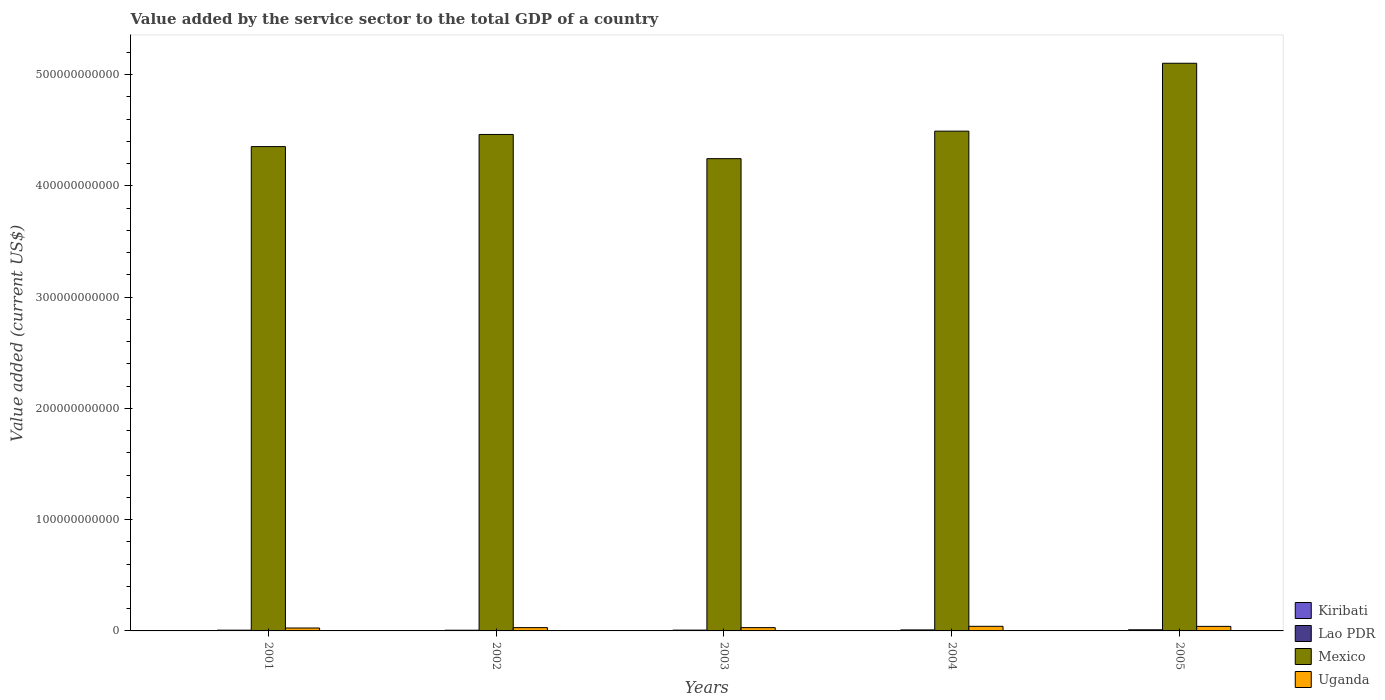How many different coloured bars are there?
Ensure brevity in your answer.  4. How many groups of bars are there?
Your response must be concise. 5. Are the number of bars on each tick of the X-axis equal?
Provide a short and direct response. Yes. How many bars are there on the 3rd tick from the right?
Your answer should be compact. 4. What is the label of the 2nd group of bars from the left?
Provide a short and direct response. 2002. In how many cases, is the number of bars for a given year not equal to the number of legend labels?
Offer a very short reply. 0. What is the value added by the service sector to the total GDP in Uganda in 2005?
Give a very brief answer. 4.08e+09. Across all years, what is the maximum value added by the service sector to the total GDP in Lao PDR?
Your answer should be very brief. 1.01e+09. Across all years, what is the minimum value added by the service sector to the total GDP in Lao PDR?
Your answer should be compact. 6.28e+08. In which year was the value added by the service sector to the total GDP in Uganda minimum?
Your answer should be compact. 2001. What is the total value added by the service sector to the total GDP in Uganda in the graph?
Provide a succinct answer. 1.67e+1. What is the difference between the value added by the service sector to the total GDP in Kiribati in 2004 and that in 2005?
Your answer should be very brief. -8.06e+06. What is the difference between the value added by the service sector to the total GDP in Mexico in 2003 and the value added by the service sector to the total GDP in Lao PDR in 2001?
Your answer should be compact. 4.24e+11. What is the average value added by the service sector to the total GDP in Lao PDR per year?
Offer a terse response. 7.89e+08. In the year 2005, what is the difference between the value added by the service sector to the total GDP in Uganda and value added by the service sector to the total GDP in Lao PDR?
Ensure brevity in your answer.  3.07e+09. In how many years, is the value added by the service sector to the total GDP in Uganda greater than 80000000000 US$?
Keep it short and to the point. 0. What is the ratio of the value added by the service sector to the total GDP in Mexico in 2004 to that in 2005?
Offer a very short reply. 0.88. Is the difference between the value added by the service sector to the total GDP in Uganda in 2001 and 2005 greater than the difference between the value added by the service sector to the total GDP in Lao PDR in 2001 and 2005?
Keep it short and to the point. No. What is the difference between the highest and the second highest value added by the service sector to the total GDP in Lao PDR?
Your answer should be very brief. 1.09e+08. What is the difference between the highest and the lowest value added by the service sector to the total GDP in Lao PDR?
Your answer should be compact. 3.85e+08. Is the sum of the value added by the service sector to the total GDP in Lao PDR in 2002 and 2004 greater than the maximum value added by the service sector to the total GDP in Mexico across all years?
Provide a succinct answer. No. Is it the case that in every year, the sum of the value added by the service sector to the total GDP in Uganda and value added by the service sector to the total GDP in Lao PDR is greater than the sum of value added by the service sector to the total GDP in Mexico and value added by the service sector to the total GDP in Kiribati?
Your response must be concise. Yes. What does the 3rd bar from the left in 2001 represents?
Make the answer very short. Mexico. What does the 1st bar from the right in 2005 represents?
Offer a terse response. Uganda. Is it the case that in every year, the sum of the value added by the service sector to the total GDP in Uganda and value added by the service sector to the total GDP in Lao PDR is greater than the value added by the service sector to the total GDP in Mexico?
Give a very brief answer. No. How many bars are there?
Offer a very short reply. 20. Are all the bars in the graph horizontal?
Make the answer very short. No. How many years are there in the graph?
Give a very brief answer. 5. What is the difference between two consecutive major ticks on the Y-axis?
Your response must be concise. 1.00e+11. Does the graph contain any zero values?
Offer a very short reply. No. Does the graph contain grids?
Give a very brief answer. No. Where does the legend appear in the graph?
Give a very brief answer. Bottom right. How many legend labels are there?
Ensure brevity in your answer.  4. What is the title of the graph?
Keep it short and to the point. Value added by the service sector to the total GDP of a country. What is the label or title of the X-axis?
Provide a short and direct response. Years. What is the label or title of the Y-axis?
Give a very brief answer. Value added (current US$). What is the Value added (current US$) of Kiribati in 2001?
Offer a terse response. 3.75e+07. What is the Value added (current US$) of Lao PDR in 2001?
Ensure brevity in your answer.  6.82e+08. What is the Value added (current US$) in Mexico in 2001?
Your answer should be very brief. 4.35e+11. What is the Value added (current US$) in Uganda in 2001?
Your answer should be very brief. 2.62e+09. What is the Value added (current US$) in Kiribati in 2002?
Offer a very short reply. 4.17e+07. What is the Value added (current US$) of Lao PDR in 2002?
Keep it short and to the point. 6.28e+08. What is the Value added (current US$) of Mexico in 2002?
Your answer should be very brief. 4.46e+11. What is the Value added (current US$) in Uganda in 2002?
Keep it short and to the point. 2.95e+09. What is the Value added (current US$) in Kiribati in 2003?
Your answer should be very brief. 5.20e+07. What is the Value added (current US$) of Lao PDR in 2003?
Give a very brief answer. 7.19e+08. What is the Value added (current US$) of Mexico in 2003?
Keep it short and to the point. 4.24e+11. What is the Value added (current US$) in Uganda in 2003?
Your answer should be very brief. 2.95e+09. What is the Value added (current US$) of Kiribati in 2004?
Offer a very short reply. 5.83e+07. What is the Value added (current US$) of Lao PDR in 2004?
Provide a succinct answer. 9.04e+08. What is the Value added (current US$) in Mexico in 2004?
Provide a short and direct response. 4.49e+11. What is the Value added (current US$) of Uganda in 2004?
Offer a terse response. 4.13e+09. What is the Value added (current US$) in Kiribati in 2005?
Your response must be concise. 6.63e+07. What is the Value added (current US$) of Lao PDR in 2005?
Your response must be concise. 1.01e+09. What is the Value added (current US$) in Mexico in 2005?
Make the answer very short. 5.10e+11. What is the Value added (current US$) of Uganda in 2005?
Ensure brevity in your answer.  4.08e+09. Across all years, what is the maximum Value added (current US$) in Kiribati?
Give a very brief answer. 6.63e+07. Across all years, what is the maximum Value added (current US$) in Lao PDR?
Provide a short and direct response. 1.01e+09. Across all years, what is the maximum Value added (current US$) in Mexico?
Ensure brevity in your answer.  5.10e+11. Across all years, what is the maximum Value added (current US$) in Uganda?
Give a very brief answer. 4.13e+09. Across all years, what is the minimum Value added (current US$) in Kiribati?
Your answer should be very brief. 3.75e+07. Across all years, what is the minimum Value added (current US$) of Lao PDR?
Provide a succinct answer. 6.28e+08. Across all years, what is the minimum Value added (current US$) in Mexico?
Make the answer very short. 4.24e+11. Across all years, what is the minimum Value added (current US$) in Uganda?
Ensure brevity in your answer.  2.62e+09. What is the total Value added (current US$) in Kiribati in the graph?
Offer a very short reply. 2.56e+08. What is the total Value added (current US$) of Lao PDR in the graph?
Provide a short and direct response. 3.94e+09. What is the total Value added (current US$) in Mexico in the graph?
Ensure brevity in your answer.  2.26e+12. What is the total Value added (current US$) of Uganda in the graph?
Provide a short and direct response. 1.67e+1. What is the difference between the Value added (current US$) in Kiribati in 2001 and that in 2002?
Offer a terse response. -4.19e+06. What is the difference between the Value added (current US$) of Lao PDR in 2001 and that in 2002?
Ensure brevity in your answer.  5.40e+07. What is the difference between the Value added (current US$) of Mexico in 2001 and that in 2002?
Make the answer very short. -1.09e+1. What is the difference between the Value added (current US$) of Uganda in 2001 and that in 2002?
Ensure brevity in your answer.  -3.34e+08. What is the difference between the Value added (current US$) in Kiribati in 2001 and that in 2003?
Your answer should be very brief. -1.45e+07. What is the difference between the Value added (current US$) of Lao PDR in 2001 and that in 2003?
Ensure brevity in your answer.  -3.73e+07. What is the difference between the Value added (current US$) in Mexico in 2001 and that in 2003?
Provide a short and direct response. 1.08e+1. What is the difference between the Value added (current US$) of Uganda in 2001 and that in 2003?
Provide a short and direct response. -3.34e+08. What is the difference between the Value added (current US$) of Kiribati in 2001 and that in 2004?
Offer a very short reply. -2.07e+07. What is the difference between the Value added (current US$) in Lao PDR in 2001 and that in 2004?
Keep it short and to the point. -2.22e+08. What is the difference between the Value added (current US$) of Mexico in 2001 and that in 2004?
Your answer should be compact. -1.39e+1. What is the difference between the Value added (current US$) of Uganda in 2001 and that in 2004?
Your answer should be compact. -1.52e+09. What is the difference between the Value added (current US$) of Kiribati in 2001 and that in 2005?
Offer a very short reply. -2.88e+07. What is the difference between the Value added (current US$) in Lao PDR in 2001 and that in 2005?
Provide a succinct answer. -3.30e+08. What is the difference between the Value added (current US$) in Mexico in 2001 and that in 2005?
Keep it short and to the point. -7.49e+1. What is the difference between the Value added (current US$) of Uganda in 2001 and that in 2005?
Make the answer very short. -1.47e+09. What is the difference between the Value added (current US$) in Kiribati in 2002 and that in 2003?
Offer a terse response. -1.03e+07. What is the difference between the Value added (current US$) of Lao PDR in 2002 and that in 2003?
Make the answer very short. -9.13e+07. What is the difference between the Value added (current US$) of Mexico in 2002 and that in 2003?
Your response must be concise. 2.17e+1. What is the difference between the Value added (current US$) in Uganda in 2002 and that in 2003?
Your answer should be compact. 7.68e+05. What is the difference between the Value added (current US$) of Kiribati in 2002 and that in 2004?
Your answer should be very brief. -1.65e+07. What is the difference between the Value added (current US$) of Lao PDR in 2002 and that in 2004?
Your answer should be compact. -2.76e+08. What is the difference between the Value added (current US$) of Mexico in 2002 and that in 2004?
Keep it short and to the point. -2.97e+09. What is the difference between the Value added (current US$) of Uganda in 2002 and that in 2004?
Offer a very short reply. -1.18e+09. What is the difference between the Value added (current US$) in Kiribati in 2002 and that in 2005?
Your answer should be very brief. -2.46e+07. What is the difference between the Value added (current US$) in Lao PDR in 2002 and that in 2005?
Your response must be concise. -3.85e+08. What is the difference between the Value added (current US$) in Mexico in 2002 and that in 2005?
Give a very brief answer. -6.40e+1. What is the difference between the Value added (current US$) in Uganda in 2002 and that in 2005?
Your response must be concise. -1.13e+09. What is the difference between the Value added (current US$) in Kiribati in 2003 and that in 2004?
Ensure brevity in your answer.  -6.27e+06. What is the difference between the Value added (current US$) of Lao PDR in 2003 and that in 2004?
Your answer should be compact. -1.85e+08. What is the difference between the Value added (current US$) of Mexico in 2003 and that in 2004?
Your response must be concise. -2.47e+1. What is the difference between the Value added (current US$) of Uganda in 2003 and that in 2004?
Offer a very short reply. -1.18e+09. What is the difference between the Value added (current US$) of Kiribati in 2003 and that in 2005?
Keep it short and to the point. -1.43e+07. What is the difference between the Value added (current US$) in Lao PDR in 2003 and that in 2005?
Your response must be concise. -2.93e+08. What is the difference between the Value added (current US$) in Mexico in 2003 and that in 2005?
Provide a short and direct response. -8.57e+1. What is the difference between the Value added (current US$) in Uganda in 2003 and that in 2005?
Your answer should be very brief. -1.14e+09. What is the difference between the Value added (current US$) of Kiribati in 2004 and that in 2005?
Offer a terse response. -8.06e+06. What is the difference between the Value added (current US$) of Lao PDR in 2004 and that in 2005?
Make the answer very short. -1.09e+08. What is the difference between the Value added (current US$) in Mexico in 2004 and that in 2005?
Provide a succinct answer. -6.10e+1. What is the difference between the Value added (current US$) of Uganda in 2004 and that in 2005?
Your answer should be compact. 4.72e+07. What is the difference between the Value added (current US$) in Kiribati in 2001 and the Value added (current US$) in Lao PDR in 2002?
Your answer should be very brief. -5.90e+08. What is the difference between the Value added (current US$) of Kiribati in 2001 and the Value added (current US$) of Mexico in 2002?
Provide a succinct answer. -4.46e+11. What is the difference between the Value added (current US$) in Kiribati in 2001 and the Value added (current US$) in Uganda in 2002?
Make the answer very short. -2.91e+09. What is the difference between the Value added (current US$) in Lao PDR in 2001 and the Value added (current US$) in Mexico in 2002?
Offer a terse response. -4.45e+11. What is the difference between the Value added (current US$) in Lao PDR in 2001 and the Value added (current US$) in Uganda in 2002?
Offer a terse response. -2.27e+09. What is the difference between the Value added (current US$) of Mexico in 2001 and the Value added (current US$) of Uganda in 2002?
Keep it short and to the point. 4.32e+11. What is the difference between the Value added (current US$) of Kiribati in 2001 and the Value added (current US$) of Lao PDR in 2003?
Offer a terse response. -6.81e+08. What is the difference between the Value added (current US$) of Kiribati in 2001 and the Value added (current US$) of Mexico in 2003?
Offer a very short reply. -4.24e+11. What is the difference between the Value added (current US$) in Kiribati in 2001 and the Value added (current US$) in Uganda in 2003?
Your response must be concise. -2.91e+09. What is the difference between the Value added (current US$) in Lao PDR in 2001 and the Value added (current US$) in Mexico in 2003?
Your answer should be compact. -4.24e+11. What is the difference between the Value added (current US$) in Lao PDR in 2001 and the Value added (current US$) in Uganda in 2003?
Offer a terse response. -2.27e+09. What is the difference between the Value added (current US$) in Mexico in 2001 and the Value added (current US$) in Uganda in 2003?
Ensure brevity in your answer.  4.32e+11. What is the difference between the Value added (current US$) in Kiribati in 2001 and the Value added (current US$) in Lao PDR in 2004?
Provide a succinct answer. -8.66e+08. What is the difference between the Value added (current US$) of Kiribati in 2001 and the Value added (current US$) of Mexico in 2004?
Provide a succinct answer. -4.49e+11. What is the difference between the Value added (current US$) in Kiribati in 2001 and the Value added (current US$) in Uganda in 2004?
Your answer should be very brief. -4.09e+09. What is the difference between the Value added (current US$) in Lao PDR in 2001 and the Value added (current US$) in Mexico in 2004?
Your answer should be compact. -4.48e+11. What is the difference between the Value added (current US$) in Lao PDR in 2001 and the Value added (current US$) in Uganda in 2004?
Provide a succinct answer. -3.45e+09. What is the difference between the Value added (current US$) in Mexico in 2001 and the Value added (current US$) in Uganda in 2004?
Keep it short and to the point. 4.31e+11. What is the difference between the Value added (current US$) of Kiribati in 2001 and the Value added (current US$) of Lao PDR in 2005?
Provide a succinct answer. -9.75e+08. What is the difference between the Value added (current US$) of Kiribati in 2001 and the Value added (current US$) of Mexico in 2005?
Give a very brief answer. -5.10e+11. What is the difference between the Value added (current US$) of Kiribati in 2001 and the Value added (current US$) of Uganda in 2005?
Make the answer very short. -4.05e+09. What is the difference between the Value added (current US$) of Lao PDR in 2001 and the Value added (current US$) of Mexico in 2005?
Offer a terse response. -5.09e+11. What is the difference between the Value added (current US$) of Lao PDR in 2001 and the Value added (current US$) of Uganda in 2005?
Ensure brevity in your answer.  -3.40e+09. What is the difference between the Value added (current US$) in Mexico in 2001 and the Value added (current US$) in Uganda in 2005?
Offer a very short reply. 4.31e+11. What is the difference between the Value added (current US$) in Kiribati in 2002 and the Value added (current US$) in Lao PDR in 2003?
Your response must be concise. -6.77e+08. What is the difference between the Value added (current US$) in Kiribati in 2002 and the Value added (current US$) in Mexico in 2003?
Your answer should be very brief. -4.24e+11. What is the difference between the Value added (current US$) of Kiribati in 2002 and the Value added (current US$) of Uganda in 2003?
Give a very brief answer. -2.91e+09. What is the difference between the Value added (current US$) in Lao PDR in 2002 and the Value added (current US$) in Mexico in 2003?
Keep it short and to the point. -4.24e+11. What is the difference between the Value added (current US$) in Lao PDR in 2002 and the Value added (current US$) in Uganda in 2003?
Offer a very short reply. -2.32e+09. What is the difference between the Value added (current US$) in Mexico in 2002 and the Value added (current US$) in Uganda in 2003?
Ensure brevity in your answer.  4.43e+11. What is the difference between the Value added (current US$) of Kiribati in 2002 and the Value added (current US$) of Lao PDR in 2004?
Your answer should be very brief. -8.62e+08. What is the difference between the Value added (current US$) in Kiribati in 2002 and the Value added (current US$) in Mexico in 2004?
Make the answer very short. -4.49e+11. What is the difference between the Value added (current US$) of Kiribati in 2002 and the Value added (current US$) of Uganda in 2004?
Give a very brief answer. -4.09e+09. What is the difference between the Value added (current US$) in Lao PDR in 2002 and the Value added (current US$) in Mexico in 2004?
Give a very brief answer. -4.48e+11. What is the difference between the Value added (current US$) in Lao PDR in 2002 and the Value added (current US$) in Uganda in 2004?
Offer a terse response. -3.50e+09. What is the difference between the Value added (current US$) in Mexico in 2002 and the Value added (current US$) in Uganda in 2004?
Ensure brevity in your answer.  4.42e+11. What is the difference between the Value added (current US$) in Kiribati in 2002 and the Value added (current US$) in Lao PDR in 2005?
Your response must be concise. -9.70e+08. What is the difference between the Value added (current US$) in Kiribati in 2002 and the Value added (current US$) in Mexico in 2005?
Your answer should be compact. -5.10e+11. What is the difference between the Value added (current US$) of Kiribati in 2002 and the Value added (current US$) of Uganda in 2005?
Your answer should be compact. -4.04e+09. What is the difference between the Value added (current US$) of Lao PDR in 2002 and the Value added (current US$) of Mexico in 2005?
Provide a short and direct response. -5.09e+11. What is the difference between the Value added (current US$) of Lao PDR in 2002 and the Value added (current US$) of Uganda in 2005?
Your answer should be very brief. -3.46e+09. What is the difference between the Value added (current US$) of Mexico in 2002 and the Value added (current US$) of Uganda in 2005?
Ensure brevity in your answer.  4.42e+11. What is the difference between the Value added (current US$) in Kiribati in 2003 and the Value added (current US$) in Lao PDR in 2004?
Provide a short and direct response. -8.52e+08. What is the difference between the Value added (current US$) of Kiribati in 2003 and the Value added (current US$) of Mexico in 2004?
Your answer should be compact. -4.49e+11. What is the difference between the Value added (current US$) in Kiribati in 2003 and the Value added (current US$) in Uganda in 2004?
Provide a short and direct response. -4.08e+09. What is the difference between the Value added (current US$) in Lao PDR in 2003 and the Value added (current US$) in Mexico in 2004?
Provide a succinct answer. -4.48e+11. What is the difference between the Value added (current US$) in Lao PDR in 2003 and the Value added (current US$) in Uganda in 2004?
Provide a short and direct response. -3.41e+09. What is the difference between the Value added (current US$) in Mexico in 2003 and the Value added (current US$) in Uganda in 2004?
Your answer should be compact. 4.20e+11. What is the difference between the Value added (current US$) of Kiribati in 2003 and the Value added (current US$) of Lao PDR in 2005?
Your response must be concise. -9.60e+08. What is the difference between the Value added (current US$) of Kiribati in 2003 and the Value added (current US$) of Mexico in 2005?
Give a very brief answer. -5.10e+11. What is the difference between the Value added (current US$) of Kiribati in 2003 and the Value added (current US$) of Uganda in 2005?
Offer a very short reply. -4.03e+09. What is the difference between the Value added (current US$) in Lao PDR in 2003 and the Value added (current US$) in Mexico in 2005?
Offer a terse response. -5.09e+11. What is the difference between the Value added (current US$) in Lao PDR in 2003 and the Value added (current US$) in Uganda in 2005?
Offer a terse response. -3.37e+09. What is the difference between the Value added (current US$) in Mexico in 2003 and the Value added (current US$) in Uganda in 2005?
Keep it short and to the point. 4.20e+11. What is the difference between the Value added (current US$) of Kiribati in 2004 and the Value added (current US$) of Lao PDR in 2005?
Provide a succinct answer. -9.54e+08. What is the difference between the Value added (current US$) in Kiribati in 2004 and the Value added (current US$) in Mexico in 2005?
Offer a terse response. -5.10e+11. What is the difference between the Value added (current US$) in Kiribati in 2004 and the Value added (current US$) in Uganda in 2005?
Give a very brief answer. -4.03e+09. What is the difference between the Value added (current US$) in Lao PDR in 2004 and the Value added (current US$) in Mexico in 2005?
Keep it short and to the point. -5.09e+11. What is the difference between the Value added (current US$) of Lao PDR in 2004 and the Value added (current US$) of Uganda in 2005?
Your answer should be very brief. -3.18e+09. What is the difference between the Value added (current US$) in Mexico in 2004 and the Value added (current US$) in Uganda in 2005?
Offer a terse response. 4.45e+11. What is the average Value added (current US$) of Kiribati per year?
Your answer should be compact. 5.12e+07. What is the average Value added (current US$) of Lao PDR per year?
Make the answer very short. 7.89e+08. What is the average Value added (current US$) in Mexico per year?
Offer a terse response. 4.53e+11. What is the average Value added (current US$) of Uganda per year?
Your answer should be very brief. 3.35e+09. In the year 2001, what is the difference between the Value added (current US$) in Kiribati and Value added (current US$) in Lao PDR?
Make the answer very short. -6.44e+08. In the year 2001, what is the difference between the Value added (current US$) of Kiribati and Value added (current US$) of Mexico?
Offer a very short reply. -4.35e+11. In the year 2001, what is the difference between the Value added (current US$) of Kiribati and Value added (current US$) of Uganda?
Your answer should be compact. -2.58e+09. In the year 2001, what is the difference between the Value added (current US$) of Lao PDR and Value added (current US$) of Mexico?
Keep it short and to the point. -4.35e+11. In the year 2001, what is the difference between the Value added (current US$) in Lao PDR and Value added (current US$) in Uganda?
Your answer should be compact. -1.93e+09. In the year 2001, what is the difference between the Value added (current US$) of Mexico and Value added (current US$) of Uganda?
Offer a very short reply. 4.33e+11. In the year 2002, what is the difference between the Value added (current US$) in Kiribati and Value added (current US$) in Lao PDR?
Your answer should be very brief. -5.86e+08. In the year 2002, what is the difference between the Value added (current US$) of Kiribati and Value added (current US$) of Mexico?
Provide a succinct answer. -4.46e+11. In the year 2002, what is the difference between the Value added (current US$) in Kiribati and Value added (current US$) in Uganda?
Offer a very short reply. -2.91e+09. In the year 2002, what is the difference between the Value added (current US$) of Lao PDR and Value added (current US$) of Mexico?
Your answer should be very brief. -4.46e+11. In the year 2002, what is the difference between the Value added (current US$) in Lao PDR and Value added (current US$) in Uganda?
Give a very brief answer. -2.32e+09. In the year 2002, what is the difference between the Value added (current US$) in Mexico and Value added (current US$) in Uganda?
Offer a very short reply. 4.43e+11. In the year 2003, what is the difference between the Value added (current US$) of Kiribati and Value added (current US$) of Lao PDR?
Your answer should be very brief. -6.67e+08. In the year 2003, what is the difference between the Value added (current US$) in Kiribati and Value added (current US$) in Mexico?
Provide a short and direct response. -4.24e+11. In the year 2003, what is the difference between the Value added (current US$) in Kiribati and Value added (current US$) in Uganda?
Your response must be concise. -2.90e+09. In the year 2003, what is the difference between the Value added (current US$) of Lao PDR and Value added (current US$) of Mexico?
Offer a very short reply. -4.24e+11. In the year 2003, what is the difference between the Value added (current US$) in Lao PDR and Value added (current US$) in Uganda?
Provide a short and direct response. -2.23e+09. In the year 2003, what is the difference between the Value added (current US$) of Mexico and Value added (current US$) of Uganda?
Give a very brief answer. 4.21e+11. In the year 2004, what is the difference between the Value added (current US$) of Kiribati and Value added (current US$) of Lao PDR?
Your answer should be compact. -8.45e+08. In the year 2004, what is the difference between the Value added (current US$) in Kiribati and Value added (current US$) in Mexico?
Ensure brevity in your answer.  -4.49e+11. In the year 2004, what is the difference between the Value added (current US$) in Kiribati and Value added (current US$) in Uganda?
Offer a terse response. -4.07e+09. In the year 2004, what is the difference between the Value added (current US$) of Lao PDR and Value added (current US$) of Mexico?
Offer a terse response. -4.48e+11. In the year 2004, what is the difference between the Value added (current US$) of Lao PDR and Value added (current US$) of Uganda?
Give a very brief answer. -3.23e+09. In the year 2004, what is the difference between the Value added (current US$) of Mexico and Value added (current US$) of Uganda?
Your answer should be compact. 4.45e+11. In the year 2005, what is the difference between the Value added (current US$) of Kiribati and Value added (current US$) of Lao PDR?
Your answer should be very brief. -9.46e+08. In the year 2005, what is the difference between the Value added (current US$) in Kiribati and Value added (current US$) in Mexico?
Offer a terse response. -5.10e+11. In the year 2005, what is the difference between the Value added (current US$) in Kiribati and Value added (current US$) in Uganda?
Offer a very short reply. -4.02e+09. In the year 2005, what is the difference between the Value added (current US$) in Lao PDR and Value added (current US$) in Mexico?
Provide a short and direct response. -5.09e+11. In the year 2005, what is the difference between the Value added (current US$) of Lao PDR and Value added (current US$) of Uganda?
Offer a very short reply. -3.07e+09. In the year 2005, what is the difference between the Value added (current US$) of Mexico and Value added (current US$) of Uganda?
Ensure brevity in your answer.  5.06e+11. What is the ratio of the Value added (current US$) of Kiribati in 2001 to that in 2002?
Make the answer very short. 0.9. What is the ratio of the Value added (current US$) in Lao PDR in 2001 to that in 2002?
Your answer should be very brief. 1.09. What is the ratio of the Value added (current US$) in Mexico in 2001 to that in 2002?
Offer a very short reply. 0.98. What is the ratio of the Value added (current US$) of Uganda in 2001 to that in 2002?
Keep it short and to the point. 0.89. What is the ratio of the Value added (current US$) in Kiribati in 2001 to that in 2003?
Offer a very short reply. 0.72. What is the ratio of the Value added (current US$) of Lao PDR in 2001 to that in 2003?
Keep it short and to the point. 0.95. What is the ratio of the Value added (current US$) in Mexico in 2001 to that in 2003?
Offer a terse response. 1.03. What is the ratio of the Value added (current US$) in Uganda in 2001 to that in 2003?
Provide a succinct answer. 0.89. What is the ratio of the Value added (current US$) of Kiribati in 2001 to that in 2004?
Give a very brief answer. 0.64. What is the ratio of the Value added (current US$) in Lao PDR in 2001 to that in 2004?
Keep it short and to the point. 0.75. What is the ratio of the Value added (current US$) of Mexico in 2001 to that in 2004?
Your answer should be compact. 0.97. What is the ratio of the Value added (current US$) of Uganda in 2001 to that in 2004?
Your response must be concise. 0.63. What is the ratio of the Value added (current US$) of Kiribati in 2001 to that in 2005?
Offer a terse response. 0.57. What is the ratio of the Value added (current US$) in Lao PDR in 2001 to that in 2005?
Provide a short and direct response. 0.67. What is the ratio of the Value added (current US$) of Mexico in 2001 to that in 2005?
Keep it short and to the point. 0.85. What is the ratio of the Value added (current US$) in Uganda in 2001 to that in 2005?
Your answer should be compact. 0.64. What is the ratio of the Value added (current US$) of Kiribati in 2002 to that in 2003?
Make the answer very short. 0.8. What is the ratio of the Value added (current US$) in Lao PDR in 2002 to that in 2003?
Give a very brief answer. 0.87. What is the ratio of the Value added (current US$) in Mexico in 2002 to that in 2003?
Offer a very short reply. 1.05. What is the ratio of the Value added (current US$) of Kiribati in 2002 to that in 2004?
Provide a succinct answer. 0.72. What is the ratio of the Value added (current US$) of Lao PDR in 2002 to that in 2004?
Your response must be concise. 0.69. What is the ratio of the Value added (current US$) in Mexico in 2002 to that in 2004?
Ensure brevity in your answer.  0.99. What is the ratio of the Value added (current US$) of Uganda in 2002 to that in 2004?
Offer a very short reply. 0.71. What is the ratio of the Value added (current US$) of Kiribati in 2002 to that in 2005?
Ensure brevity in your answer.  0.63. What is the ratio of the Value added (current US$) of Lao PDR in 2002 to that in 2005?
Your answer should be very brief. 0.62. What is the ratio of the Value added (current US$) in Mexico in 2002 to that in 2005?
Give a very brief answer. 0.87. What is the ratio of the Value added (current US$) of Uganda in 2002 to that in 2005?
Your answer should be compact. 0.72. What is the ratio of the Value added (current US$) of Kiribati in 2003 to that in 2004?
Ensure brevity in your answer.  0.89. What is the ratio of the Value added (current US$) of Lao PDR in 2003 to that in 2004?
Your answer should be compact. 0.8. What is the ratio of the Value added (current US$) of Mexico in 2003 to that in 2004?
Keep it short and to the point. 0.94. What is the ratio of the Value added (current US$) in Uganda in 2003 to that in 2004?
Keep it short and to the point. 0.71. What is the ratio of the Value added (current US$) in Kiribati in 2003 to that in 2005?
Your answer should be very brief. 0.78. What is the ratio of the Value added (current US$) in Lao PDR in 2003 to that in 2005?
Give a very brief answer. 0.71. What is the ratio of the Value added (current US$) in Mexico in 2003 to that in 2005?
Provide a succinct answer. 0.83. What is the ratio of the Value added (current US$) in Uganda in 2003 to that in 2005?
Your answer should be very brief. 0.72. What is the ratio of the Value added (current US$) in Kiribati in 2004 to that in 2005?
Offer a very short reply. 0.88. What is the ratio of the Value added (current US$) in Lao PDR in 2004 to that in 2005?
Your answer should be compact. 0.89. What is the ratio of the Value added (current US$) in Mexico in 2004 to that in 2005?
Provide a short and direct response. 0.88. What is the ratio of the Value added (current US$) in Uganda in 2004 to that in 2005?
Give a very brief answer. 1.01. What is the difference between the highest and the second highest Value added (current US$) in Kiribati?
Offer a very short reply. 8.06e+06. What is the difference between the highest and the second highest Value added (current US$) in Lao PDR?
Keep it short and to the point. 1.09e+08. What is the difference between the highest and the second highest Value added (current US$) in Mexico?
Offer a terse response. 6.10e+1. What is the difference between the highest and the second highest Value added (current US$) of Uganda?
Your answer should be very brief. 4.72e+07. What is the difference between the highest and the lowest Value added (current US$) in Kiribati?
Your answer should be very brief. 2.88e+07. What is the difference between the highest and the lowest Value added (current US$) of Lao PDR?
Offer a very short reply. 3.85e+08. What is the difference between the highest and the lowest Value added (current US$) in Mexico?
Offer a very short reply. 8.57e+1. What is the difference between the highest and the lowest Value added (current US$) in Uganda?
Give a very brief answer. 1.52e+09. 